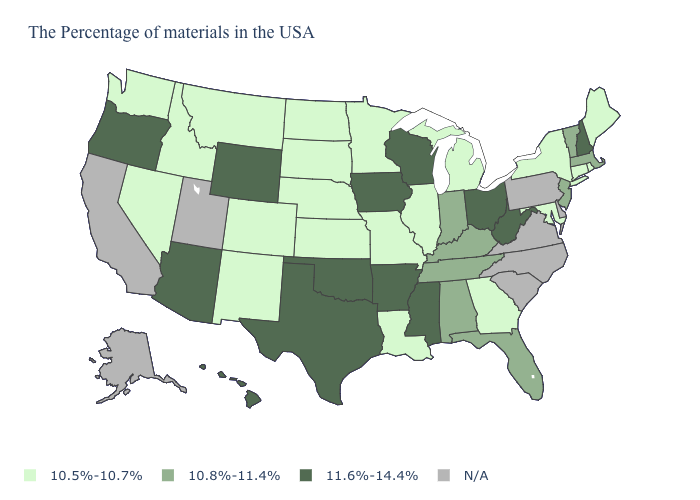Name the states that have a value in the range 11.6%-14.4%?
Answer briefly. New Hampshire, West Virginia, Ohio, Wisconsin, Mississippi, Arkansas, Iowa, Oklahoma, Texas, Wyoming, Arizona, Oregon, Hawaii. Name the states that have a value in the range 10.8%-11.4%?
Concise answer only. Massachusetts, Vermont, New Jersey, Florida, Kentucky, Indiana, Alabama, Tennessee. Name the states that have a value in the range 10.5%-10.7%?
Write a very short answer. Maine, Rhode Island, Connecticut, New York, Maryland, Georgia, Michigan, Illinois, Louisiana, Missouri, Minnesota, Kansas, Nebraska, South Dakota, North Dakota, Colorado, New Mexico, Montana, Idaho, Nevada, Washington. Name the states that have a value in the range 10.5%-10.7%?
Write a very short answer. Maine, Rhode Island, Connecticut, New York, Maryland, Georgia, Michigan, Illinois, Louisiana, Missouri, Minnesota, Kansas, Nebraska, South Dakota, North Dakota, Colorado, New Mexico, Montana, Idaho, Nevada, Washington. What is the value of Oklahoma?
Be succinct. 11.6%-14.4%. Does Idaho have the highest value in the West?
Write a very short answer. No. What is the highest value in the USA?
Answer briefly. 11.6%-14.4%. Name the states that have a value in the range 11.6%-14.4%?
Be succinct. New Hampshire, West Virginia, Ohio, Wisconsin, Mississippi, Arkansas, Iowa, Oklahoma, Texas, Wyoming, Arizona, Oregon, Hawaii. Does Vermont have the lowest value in the Northeast?
Write a very short answer. No. Does the map have missing data?
Concise answer only. Yes. What is the highest value in the USA?
Short answer required. 11.6%-14.4%. What is the highest value in the USA?
Quick response, please. 11.6%-14.4%. Among the states that border Texas , does Arkansas have the lowest value?
Concise answer only. No. 